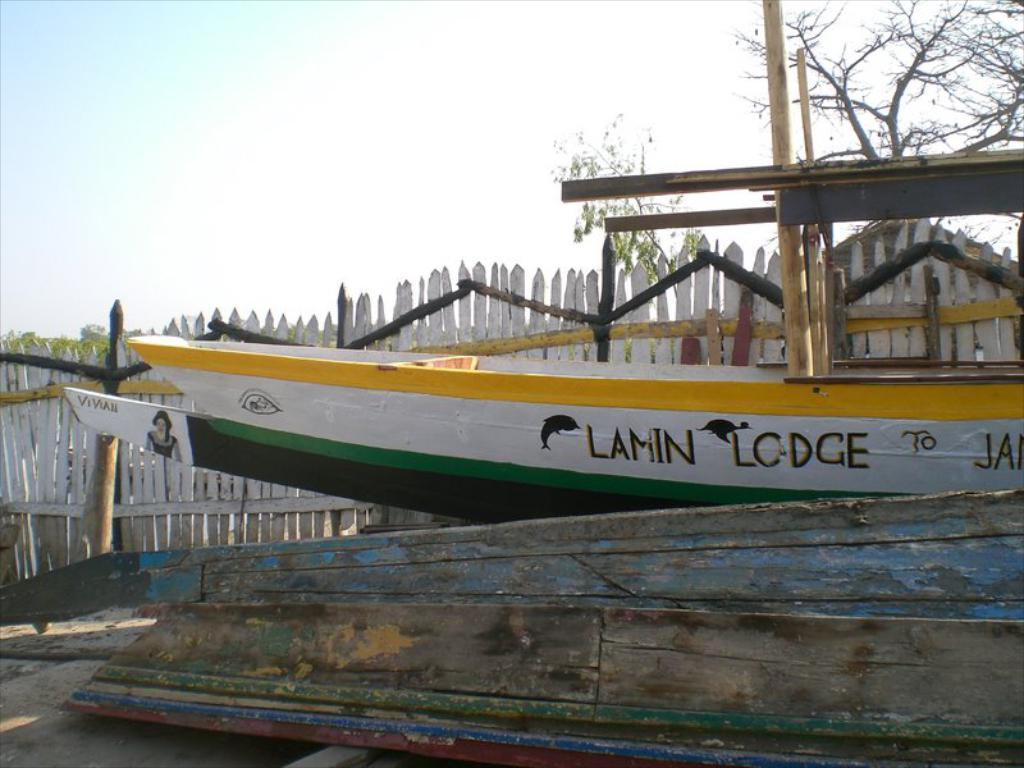What is the main subject in the middle of the image? There is a ship in the middle of the image. What can be seen in the background of the image? There is a fencing in the background of the image. What type of vegetation is on the right side of the image? There is a tree on the right side of the image. What is visible at the top of the image? The sky is visible at the top of the image. What type of organization is depicted on the ship in the image? There is no organization depicted on the ship in the image; it is a ship without any visible logos or affiliations. How many fowl can be seen on the ship in the image? There are no fowl present on the ship in the image. 